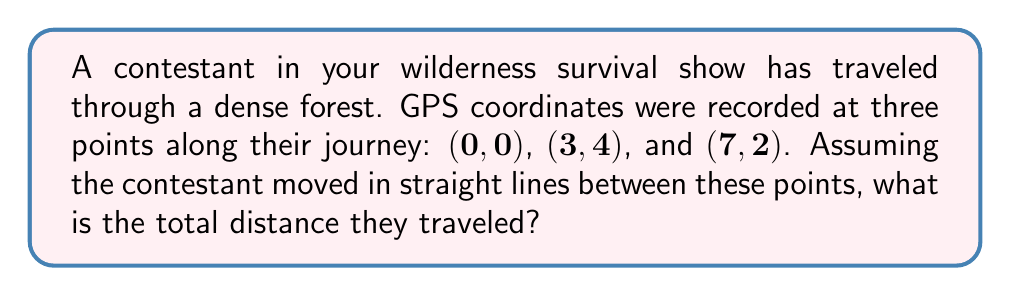Teach me how to tackle this problem. To solve this problem, we need to calculate the distances between each pair of consecutive points and sum them up. We can use the distance formula between two points $(x_1, y_1)$ and $(x_2, y_2)$:

$$d = \sqrt{(x_2-x_1)^2 + (y_2-y_1)^2}$$

Step 1: Calculate the distance from $(0,0)$ to $(3,4)$
$$d_1 = \sqrt{(3-0)^2 + (4-0)^2} = \sqrt{9 + 16} = \sqrt{25} = 5$$

Step 2: Calculate the distance from $(3,4)$ to $(7,2)$
$$d_2 = \sqrt{(7-3)^2 + (2-4)^2} = \sqrt{16 + 4} = \sqrt{20} = 2\sqrt{5}$$

Step 3: Sum up the distances
Total distance = $d_1 + d_2 = 5 + 2\sqrt{5}$

Step 4: Simplify the expression (optional)
$5 + 2\sqrt{5} \approx 9.47$ units

Therefore, the total distance traveled by the contestant is $5 + 2\sqrt{5}$ units, or approximately 9.47 units.
Answer: $5 + 2\sqrt{5}$ units 